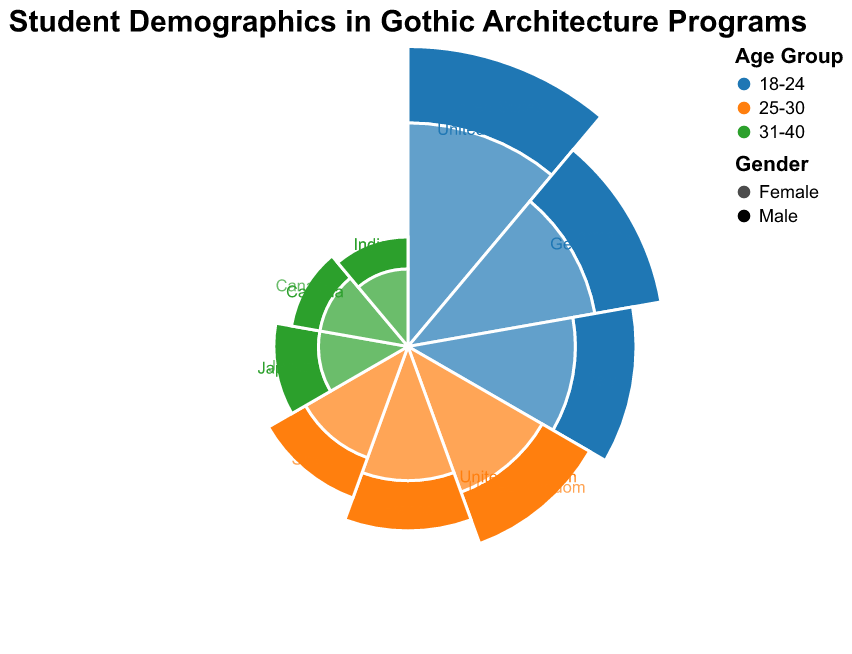What is the title of the chart? The title of the chart is prominently displayed at the top center. The text is "Student Demographics in Gothic Architecture Programs."
Answer: Student Demographics in Gothic Architecture Programs Which nationality has the highest number of students in the 18-24 age group? By looking at the largest radii for the 18-24 age group color, the United States has the highest number of students, with male and female students contributing to the highest counts in this age group.
Answer: United States How many students are there in the 25-30 age group from Spain? Add the number of Spanish students within the 25-30 age group for both genders. There are 6 males and 7 females, totaling 6 + 7 = 13 students.
Answer: 13 Which country has the least number of students in the 31-40 age group? Observe the smallest radii for the 31-40 age group colors. Canada has the least number of students in this age group, with only 3 males and 4 females, totaling 7 students.
Answer: Canada Compare the number of students from Germany and Italy in the 18-24 age group. Which country has more students? Add the total number of students from Germany (15 males + 18 females = 33 students) and from Italy (12 males + 14 females = 26 students). Germany has more students.
Answer: Germany For the 25-30 age group, which gender has more students on average across all nationalities? Calculate the average number of students for each gender across the total of 6 nationalities. Males have (10+8+6) / 3 countries = 24 / 3 = 8 on average, and females have (12+9+7) / 3 countries = 28 / 3 ~ 9.33 on average. Females have more students.
Answer: Females What’s the total number of male students in the 31-40 age group across all nationalities? Sum the number of male students in the 31-40 age group: 5 (Japan) + 3 (Canada) + 3 (India) = 11 students.
Answer: 11 How does the number of female students from the United Kingdom compare across the 18-24 and 25-30 age groups? The United Kingdom only appears in the 25-30 age group with 12 female students; hence there’s no need to compare as there are no students in the 18-24 age group.
Answer: 12 (25-30 age group), 0 (18-24 age group) Which two nationalities have the same number of students in the 31-40 age group? Inspect the radii for the 31-40 age group. Canada and India both have 3 males and 3 females, totaling 6 students each in this age group.
Answer: Canada and India 